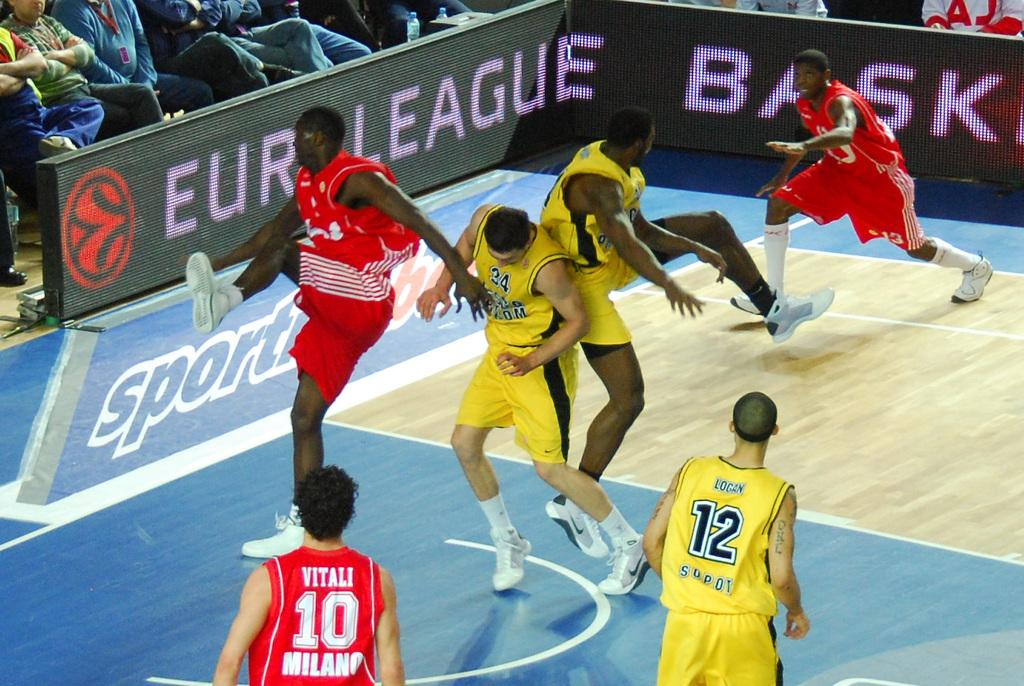<image>
Offer a succinct explanation of the picture presented. Two Euro League basketball teams on a court with one team dressed in red and another team in yellow as they are being looked at by a crowd 